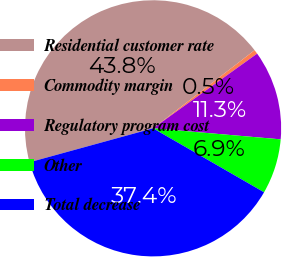Convert chart. <chart><loc_0><loc_0><loc_500><loc_500><pie_chart><fcel>Residential customer rate<fcel>Commodity margin<fcel>Regulatory program cost<fcel>Other<fcel>Total decrease<nl><fcel>43.83%<fcel>0.53%<fcel>11.28%<fcel>6.95%<fcel>37.41%<nl></chart> 